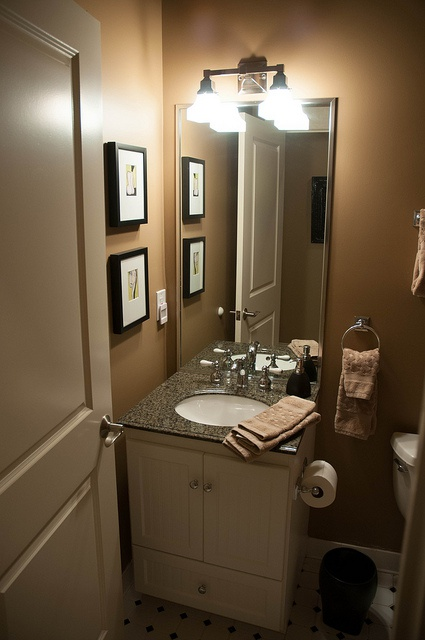Describe the objects in this image and their specific colors. I can see toilet in black and gray tones, sink in black, tan, lightgray, and gray tones, bottle in black, maroon, and gray tones, sink in black, beige, darkgray, and gray tones, and bottle in black, gray, and darkgreen tones in this image. 